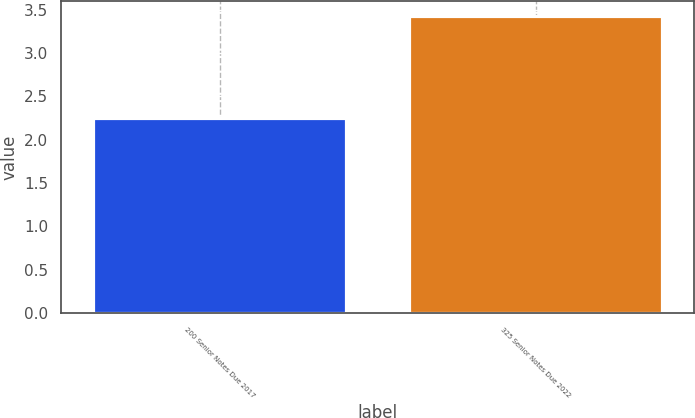Convert chart. <chart><loc_0><loc_0><loc_500><loc_500><bar_chart><fcel>200 Senior Notes Due 2017<fcel>325 Senior Notes Due 2022<nl><fcel>2.25<fcel>3.43<nl></chart> 